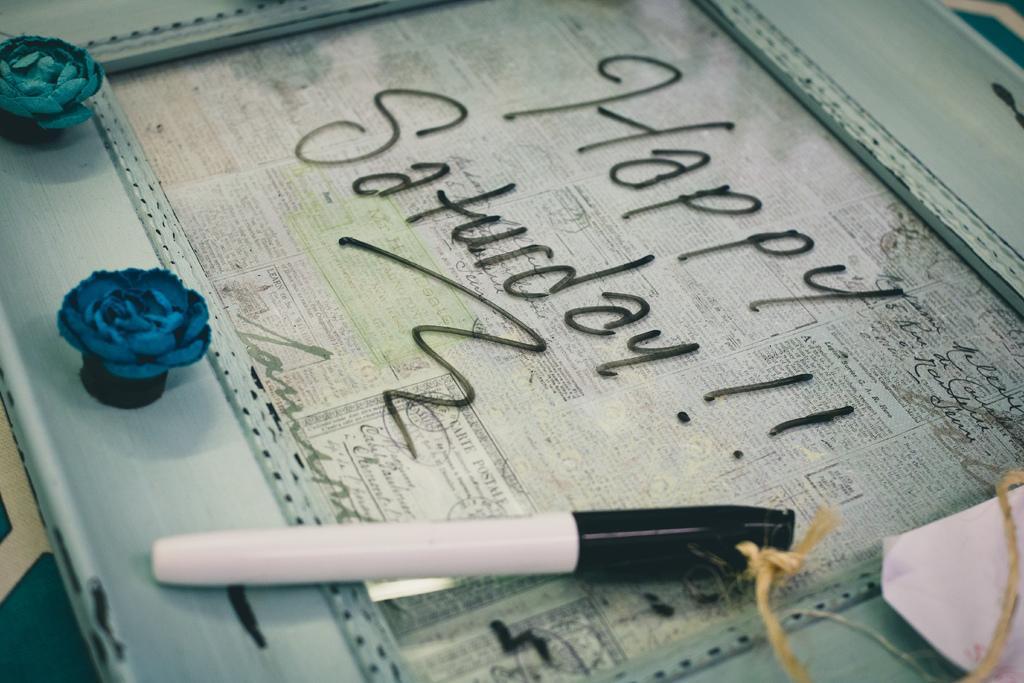Describe this image in one or two sentences. In the foreground of this image, there is a photo frame on which a marker, rope and a paper on it and there is also text written on it as "HAPPY SATURDAY !!". 